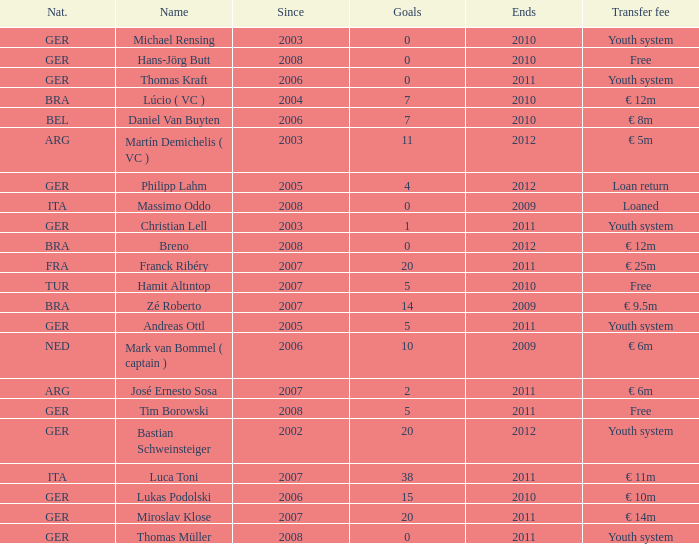What is the earliest year since which had a transfer fee of € 14m and concluded post-2011? None. 